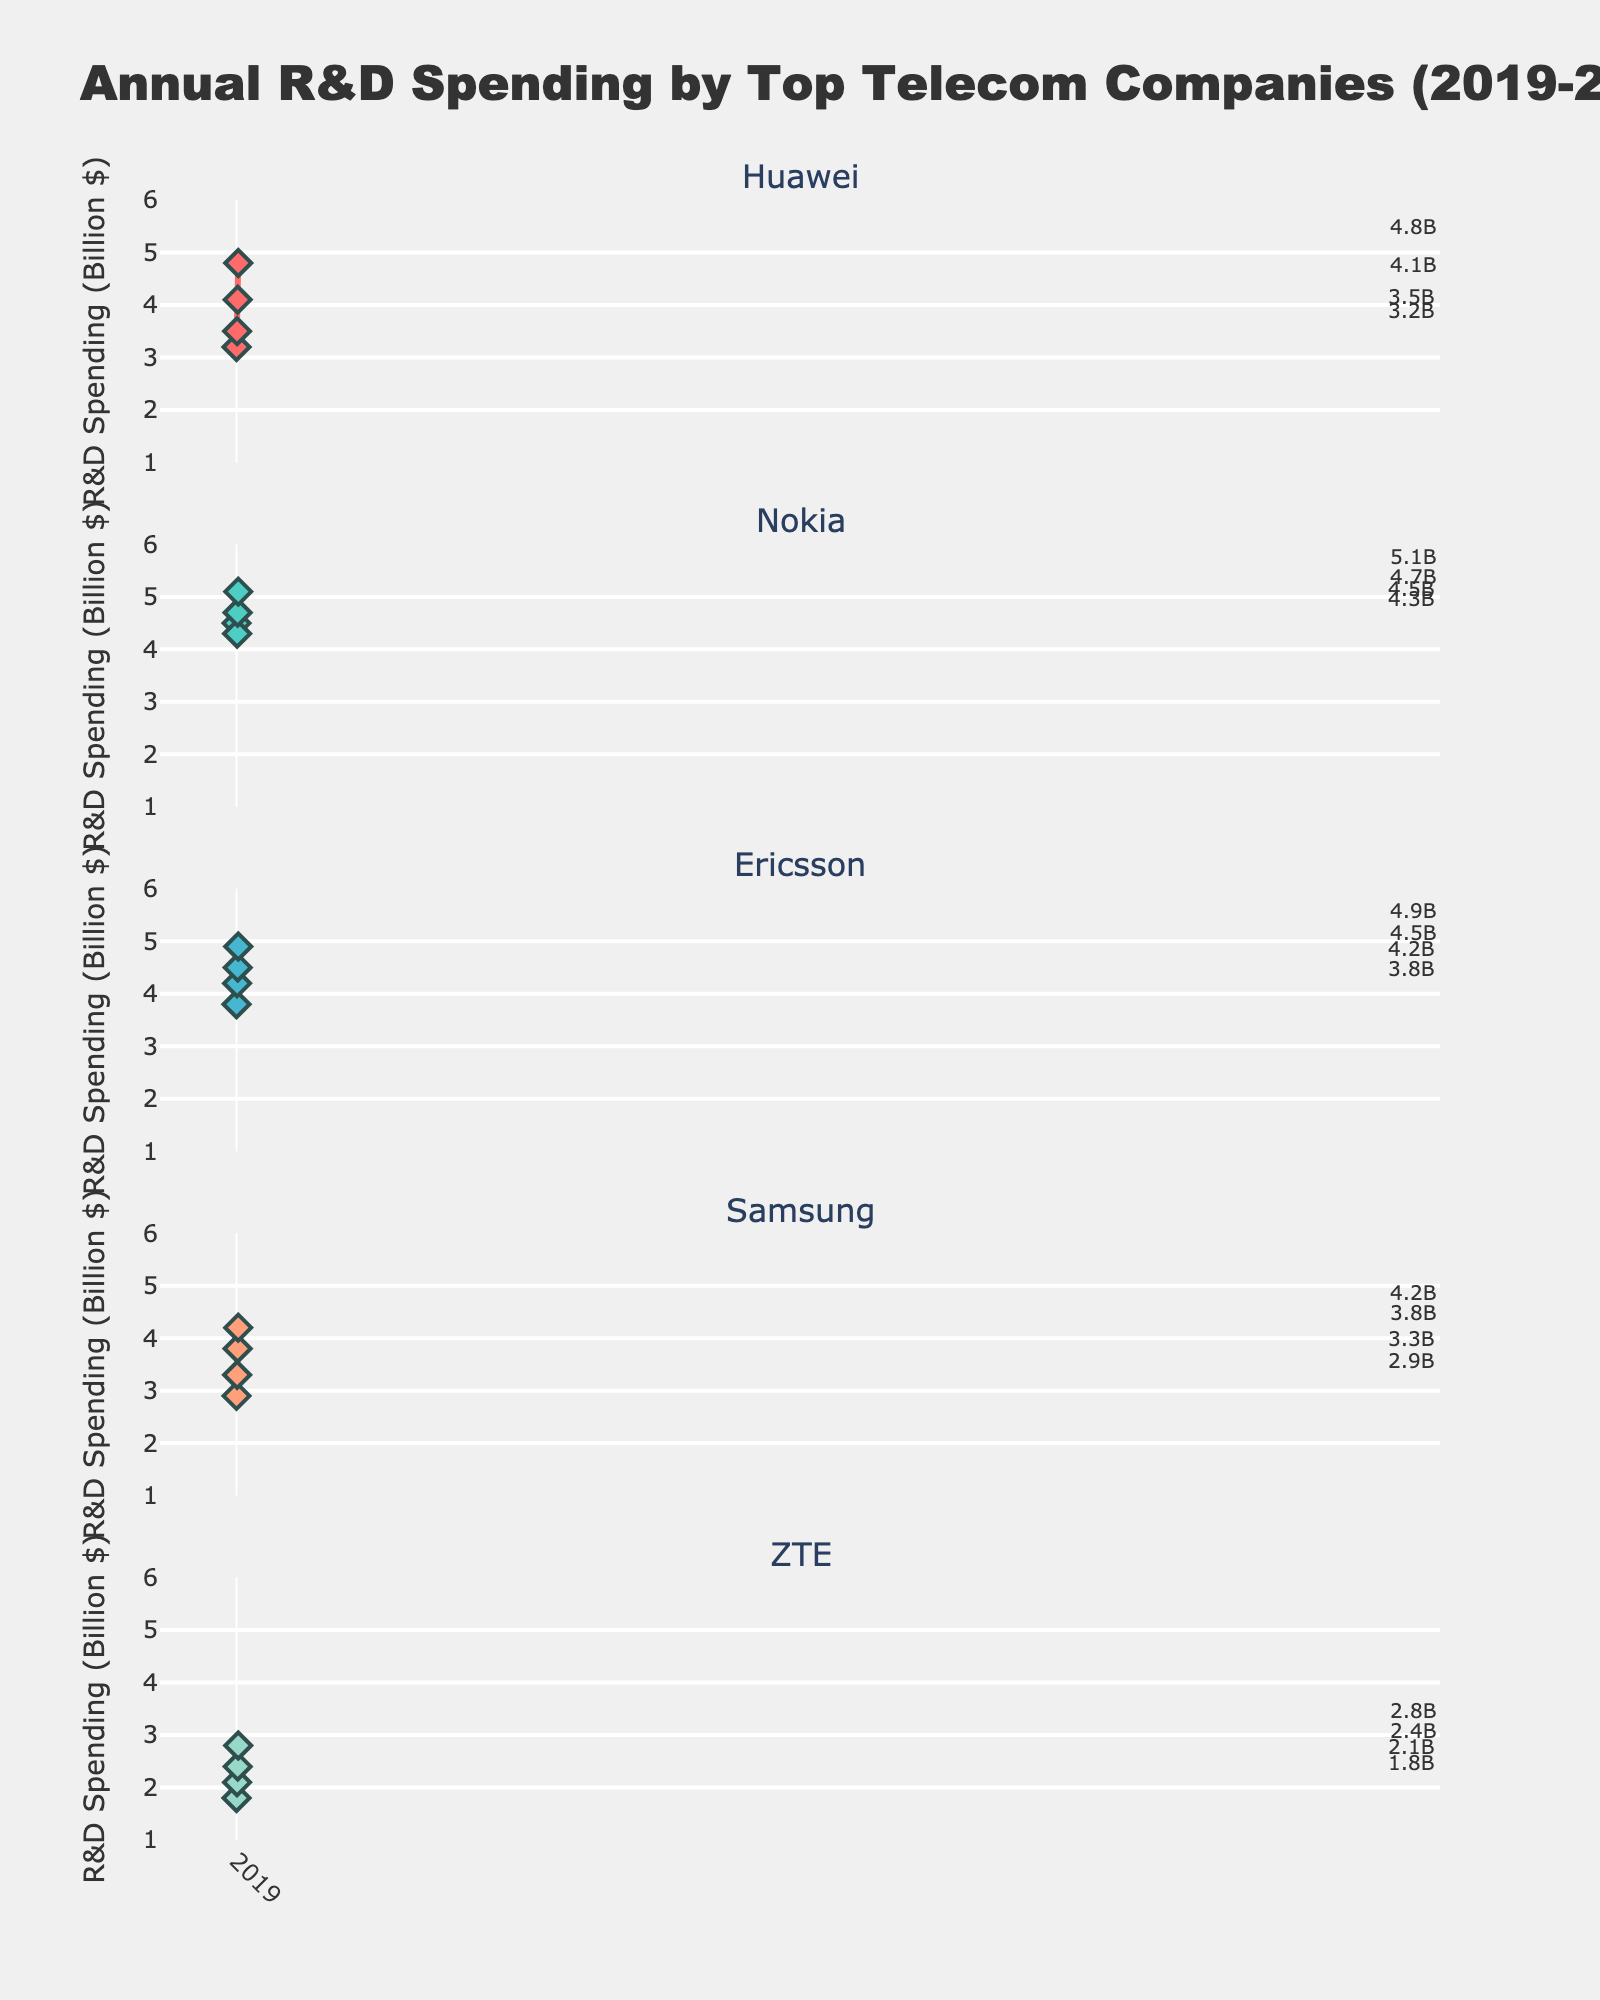What is the overall title of the figure? The overall title is prominently displayed at the top of the figure, summarizing the main purpose of the data being visualized.
Answer: Annual R&D Spending by Top Telecom Companies (2019-2022) Which company had the highest R&D spending in 2022? Looking at the y-values for each subplot in the year 2022, compare the data points.
Answer: Nokia What is the color used for Ericsson's subplot line? Identify the color of the line used in the subplot for Ericsson by looking at its visual representation.
Answer: Blue How many companies' R&D spending are plotted in the figure? Count the number of subplots or subplot titles representing each company.
Answer: 5 Which year did Huawei experience the highest R&D spending? For the Huawei subplot, compare the y-values for each year to find the highest one.
Answer: 2022 By how much did Samsung's R&D spending increase from 2019 to 2021? Subtract the R&D spending in 2019 from the spending in 2021 for Samsung's subplot.
Answer: 0.9 billion Which company showed the least variation in R&D spending from 2019 to 2022? Look at the difference between the maximum and minimum spending in y-values for each company's subplot to determine the smallest variation.
Answer: ZTE In which year did most companies experience an increase in R&D spending compared to the previous year? Compare the y-values for each year for each company's subplot to identify the year when most increases occurred.
Answer: 2021 Identify the company with the most continuous upward trend in R&D spending from 2019 to 2022. Check each company's subplot for a consistently increasing y-value pattern across all years.
Answer: Huawei What is the average R&D spending of Nokia from 2019 to 2022? Add the R&D spending values for Nokia from 2019 to 2022 and divide the sum by the number of years.
Answer: 4.65 billion 